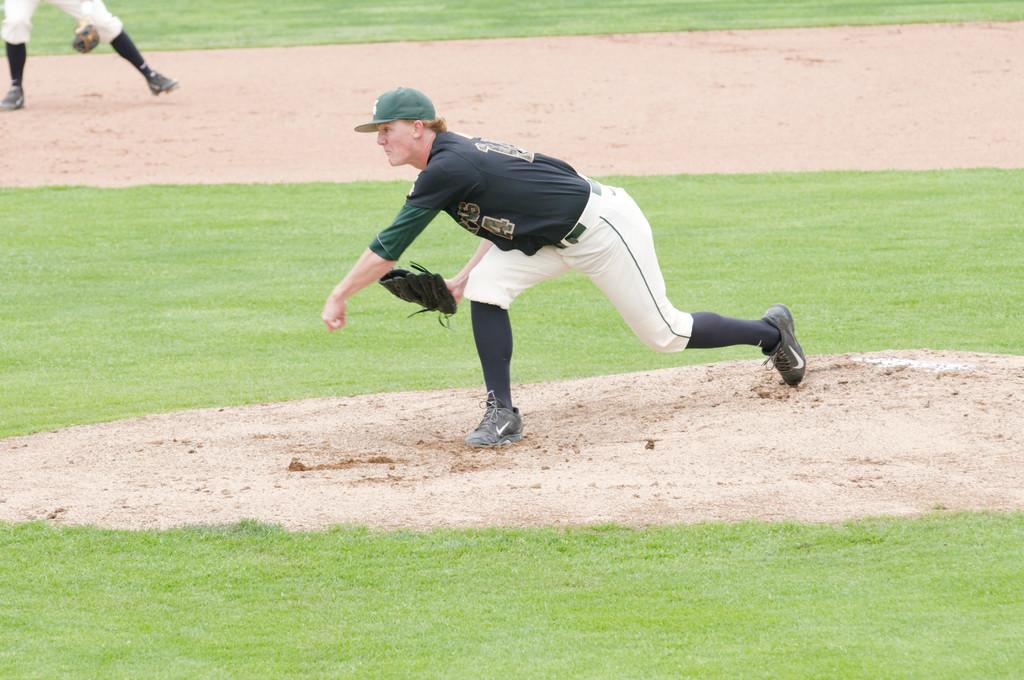What is the person in the image wearing on their head? The person in the image is wearing a cap. What direction is the person bending towards? The person is bending towards the left. Can you describe the setting of the image? The image appears to be taken in a stadium. Are there any other people visible in the image? Yes, there is another person visible in the top left corner of the image. What time does the owner of the cap set their alarm clock for in the image? There is no information about an alarm clock or the owner of the cap in the image. 